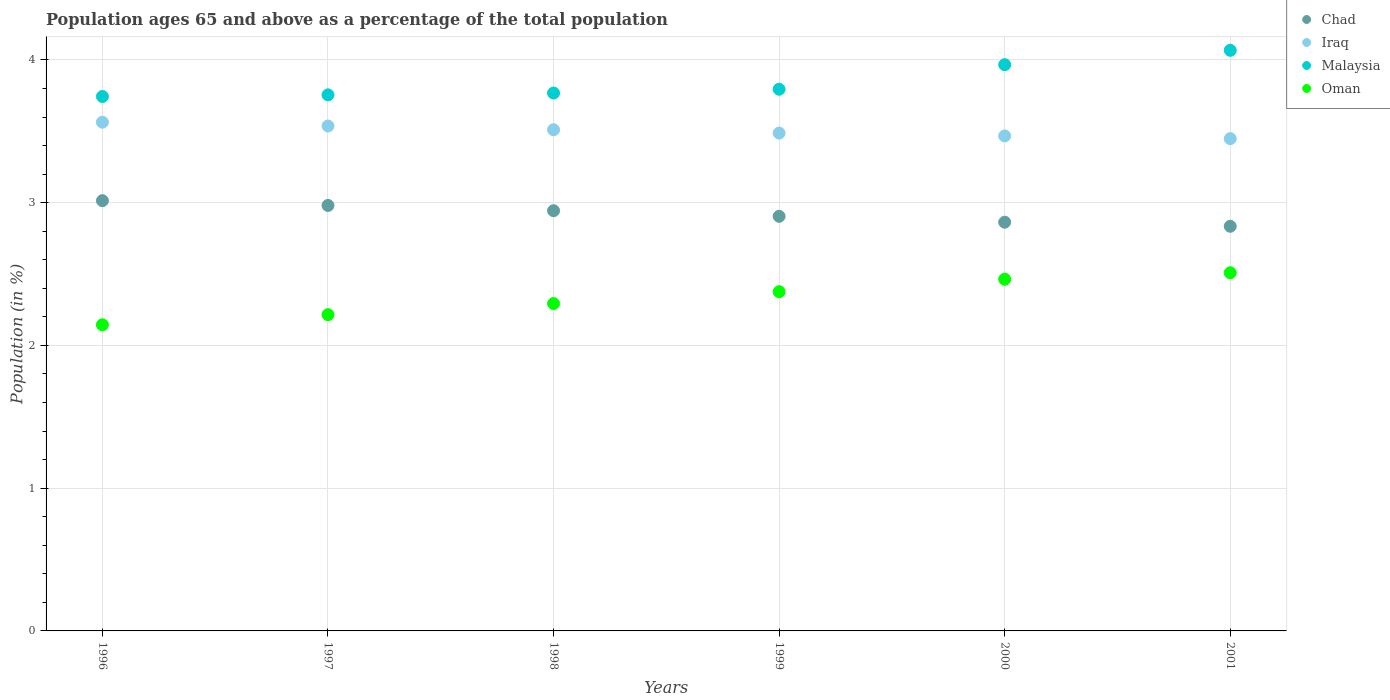How many different coloured dotlines are there?
Your response must be concise. 4. Is the number of dotlines equal to the number of legend labels?
Keep it short and to the point. Yes. What is the percentage of the population ages 65 and above in Iraq in 1996?
Provide a short and direct response. 3.56. Across all years, what is the maximum percentage of the population ages 65 and above in Iraq?
Provide a short and direct response. 3.56. Across all years, what is the minimum percentage of the population ages 65 and above in Iraq?
Keep it short and to the point. 3.45. In which year was the percentage of the population ages 65 and above in Malaysia maximum?
Give a very brief answer. 2001. In which year was the percentage of the population ages 65 and above in Malaysia minimum?
Offer a terse response. 1996. What is the total percentage of the population ages 65 and above in Oman in the graph?
Your answer should be compact. 14. What is the difference between the percentage of the population ages 65 and above in Malaysia in 1997 and that in 2000?
Ensure brevity in your answer.  -0.21. What is the difference between the percentage of the population ages 65 and above in Oman in 1997 and the percentage of the population ages 65 and above in Malaysia in 1996?
Offer a very short reply. -1.53. What is the average percentage of the population ages 65 and above in Chad per year?
Your answer should be very brief. 2.92. In the year 2000, what is the difference between the percentage of the population ages 65 and above in Iraq and percentage of the population ages 65 and above in Oman?
Your answer should be very brief. 1. What is the ratio of the percentage of the population ages 65 and above in Oman in 1998 to that in 2000?
Your answer should be compact. 0.93. Is the percentage of the population ages 65 and above in Malaysia in 1997 less than that in 1999?
Offer a terse response. Yes. What is the difference between the highest and the second highest percentage of the population ages 65 and above in Malaysia?
Give a very brief answer. 0.1. What is the difference between the highest and the lowest percentage of the population ages 65 and above in Malaysia?
Your answer should be very brief. 0.32. How many years are there in the graph?
Offer a terse response. 6. Are the values on the major ticks of Y-axis written in scientific E-notation?
Your answer should be compact. No. Does the graph contain any zero values?
Offer a terse response. No. Does the graph contain grids?
Give a very brief answer. Yes. Where does the legend appear in the graph?
Provide a short and direct response. Top right. How many legend labels are there?
Give a very brief answer. 4. What is the title of the graph?
Offer a terse response. Population ages 65 and above as a percentage of the total population. Does "Mauritania" appear as one of the legend labels in the graph?
Give a very brief answer. No. What is the label or title of the X-axis?
Keep it short and to the point. Years. What is the label or title of the Y-axis?
Make the answer very short. Population (in %). What is the Population (in %) of Chad in 1996?
Provide a succinct answer. 3.01. What is the Population (in %) of Iraq in 1996?
Your answer should be very brief. 3.56. What is the Population (in %) of Malaysia in 1996?
Your answer should be very brief. 3.74. What is the Population (in %) of Oman in 1996?
Your response must be concise. 2.14. What is the Population (in %) in Chad in 1997?
Offer a very short reply. 2.98. What is the Population (in %) in Iraq in 1997?
Give a very brief answer. 3.54. What is the Population (in %) in Malaysia in 1997?
Make the answer very short. 3.76. What is the Population (in %) in Oman in 1997?
Provide a short and direct response. 2.22. What is the Population (in %) in Chad in 1998?
Ensure brevity in your answer.  2.94. What is the Population (in %) in Iraq in 1998?
Offer a terse response. 3.51. What is the Population (in %) of Malaysia in 1998?
Offer a terse response. 3.77. What is the Population (in %) in Oman in 1998?
Your answer should be very brief. 2.29. What is the Population (in %) in Chad in 1999?
Give a very brief answer. 2.9. What is the Population (in %) of Iraq in 1999?
Provide a succinct answer. 3.49. What is the Population (in %) of Malaysia in 1999?
Keep it short and to the point. 3.79. What is the Population (in %) in Oman in 1999?
Ensure brevity in your answer.  2.38. What is the Population (in %) in Chad in 2000?
Ensure brevity in your answer.  2.86. What is the Population (in %) of Iraq in 2000?
Ensure brevity in your answer.  3.47. What is the Population (in %) of Malaysia in 2000?
Offer a very short reply. 3.97. What is the Population (in %) in Oman in 2000?
Provide a succinct answer. 2.46. What is the Population (in %) in Chad in 2001?
Keep it short and to the point. 2.83. What is the Population (in %) in Iraq in 2001?
Your response must be concise. 3.45. What is the Population (in %) of Malaysia in 2001?
Make the answer very short. 4.07. What is the Population (in %) of Oman in 2001?
Ensure brevity in your answer.  2.51. Across all years, what is the maximum Population (in %) in Chad?
Your answer should be compact. 3.01. Across all years, what is the maximum Population (in %) in Iraq?
Offer a very short reply. 3.56. Across all years, what is the maximum Population (in %) in Malaysia?
Offer a very short reply. 4.07. Across all years, what is the maximum Population (in %) of Oman?
Provide a short and direct response. 2.51. Across all years, what is the minimum Population (in %) of Chad?
Offer a very short reply. 2.83. Across all years, what is the minimum Population (in %) of Iraq?
Your answer should be very brief. 3.45. Across all years, what is the minimum Population (in %) in Malaysia?
Your answer should be compact. 3.74. Across all years, what is the minimum Population (in %) in Oman?
Give a very brief answer. 2.14. What is the total Population (in %) of Chad in the graph?
Keep it short and to the point. 17.54. What is the total Population (in %) in Iraq in the graph?
Your answer should be very brief. 21.02. What is the total Population (in %) in Malaysia in the graph?
Your answer should be very brief. 23.1. What is the total Population (in %) in Oman in the graph?
Offer a terse response. 14. What is the difference between the Population (in %) in Chad in 1996 and that in 1997?
Keep it short and to the point. 0.03. What is the difference between the Population (in %) in Iraq in 1996 and that in 1997?
Offer a terse response. 0.03. What is the difference between the Population (in %) in Malaysia in 1996 and that in 1997?
Your response must be concise. -0.01. What is the difference between the Population (in %) in Oman in 1996 and that in 1997?
Offer a very short reply. -0.07. What is the difference between the Population (in %) of Chad in 1996 and that in 1998?
Provide a succinct answer. 0.07. What is the difference between the Population (in %) in Iraq in 1996 and that in 1998?
Ensure brevity in your answer.  0.05. What is the difference between the Population (in %) in Malaysia in 1996 and that in 1998?
Offer a terse response. -0.02. What is the difference between the Population (in %) of Oman in 1996 and that in 1998?
Make the answer very short. -0.15. What is the difference between the Population (in %) of Chad in 1996 and that in 1999?
Keep it short and to the point. 0.11. What is the difference between the Population (in %) in Iraq in 1996 and that in 1999?
Your answer should be very brief. 0.08. What is the difference between the Population (in %) in Malaysia in 1996 and that in 1999?
Make the answer very short. -0.05. What is the difference between the Population (in %) of Oman in 1996 and that in 1999?
Your answer should be compact. -0.23. What is the difference between the Population (in %) of Chad in 1996 and that in 2000?
Make the answer very short. 0.15. What is the difference between the Population (in %) of Iraq in 1996 and that in 2000?
Your answer should be very brief. 0.1. What is the difference between the Population (in %) of Malaysia in 1996 and that in 2000?
Make the answer very short. -0.22. What is the difference between the Population (in %) in Oman in 1996 and that in 2000?
Provide a succinct answer. -0.32. What is the difference between the Population (in %) of Chad in 1996 and that in 2001?
Offer a terse response. 0.18. What is the difference between the Population (in %) in Iraq in 1996 and that in 2001?
Your answer should be very brief. 0.12. What is the difference between the Population (in %) of Malaysia in 1996 and that in 2001?
Provide a short and direct response. -0.32. What is the difference between the Population (in %) of Oman in 1996 and that in 2001?
Offer a very short reply. -0.36. What is the difference between the Population (in %) of Chad in 1997 and that in 1998?
Offer a very short reply. 0.04. What is the difference between the Population (in %) in Iraq in 1997 and that in 1998?
Provide a short and direct response. 0.03. What is the difference between the Population (in %) of Malaysia in 1997 and that in 1998?
Your response must be concise. -0.01. What is the difference between the Population (in %) in Oman in 1997 and that in 1998?
Keep it short and to the point. -0.08. What is the difference between the Population (in %) in Chad in 1997 and that in 1999?
Offer a terse response. 0.08. What is the difference between the Population (in %) in Iraq in 1997 and that in 1999?
Offer a very short reply. 0.05. What is the difference between the Population (in %) of Malaysia in 1997 and that in 1999?
Make the answer very short. -0.04. What is the difference between the Population (in %) of Oman in 1997 and that in 1999?
Your answer should be very brief. -0.16. What is the difference between the Population (in %) in Chad in 1997 and that in 2000?
Provide a short and direct response. 0.12. What is the difference between the Population (in %) of Iraq in 1997 and that in 2000?
Provide a short and direct response. 0.07. What is the difference between the Population (in %) of Malaysia in 1997 and that in 2000?
Make the answer very short. -0.21. What is the difference between the Population (in %) in Oman in 1997 and that in 2000?
Provide a succinct answer. -0.25. What is the difference between the Population (in %) in Chad in 1997 and that in 2001?
Your response must be concise. 0.15. What is the difference between the Population (in %) of Iraq in 1997 and that in 2001?
Make the answer very short. 0.09. What is the difference between the Population (in %) in Malaysia in 1997 and that in 2001?
Offer a terse response. -0.31. What is the difference between the Population (in %) in Oman in 1997 and that in 2001?
Make the answer very short. -0.29. What is the difference between the Population (in %) in Chad in 1998 and that in 1999?
Provide a short and direct response. 0.04. What is the difference between the Population (in %) of Iraq in 1998 and that in 1999?
Keep it short and to the point. 0.02. What is the difference between the Population (in %) in Malaysia in 1998 and that in 1999?
Give a very brief answer. -0.03. What is the difference between the Population (in %) in Oman in 1998 and that in 1999?
Your answer should be compact. -0.08. What is the difference between the Population (in %) of Chad in 1998 and that in 2000?
Your response must be concise. 0.08. What is the difference between the Population (in %) in Iraq in 1998 and that in 2000?
Give a very brief answer. 0.04. What is the difference between the Population (in %) in Malaysia in 1998 and that in 2000?
Your answer should be very brief. -0.2. What is the difference between the Population (in %) of Oman in 1998 and that in 2000?
Give a very brief answer. -0.17. What is the difference between the Population (in %) of Chad in 1998 and that in 2001?
Offer a terse response. 0.11. What is the difference between the Population (in %) in Iraq in 1998 and that in 2001?
Provide a short and direct response. 0.06. What is the difference between the Population (in %) of Malaysia in 1998 and that in 2001?
Keep it short and to the point. -0.3. What is the difference between the Population (in %) in Oman in 1998 and that in 2001?
Make the answer very short. -0.22. What is the difference between the Population (in %) of Chad in 1999 and that in 2000?
Your answer should be very brief. 0.04. What is the difference between the Population (in %) in Iraq in 1999 and that in 2000?
Your response must be concise. 0.02. What is the difference between the Population (in %) of Malaysia in 1999 and that in 2000?
Ensure brevity in your answer.  -0.17. What is the difference between the Population (in %) in Oman in 1999 and that in 2000?
Give a very brief answer. -0.09. What is the difference between the Population (in %) in Chad in 1999 and that in 2001?
Your response must be concise. 0.07. What is the difference between the Population (in %) in Iraq in 1999 and that in 2001?
Your response must be concise. 0.04. What is the difference between the Population (in %) of Malaysia in 1999 and that in 2001?
Provide a succinct answer. -0.27. What is the difference between the Population (in %) of Oman in 1999 and that in 2001?
Provide a succinct answer. -0.13. What is the difference between the Population (in %) in Chad in 2000 and that in 2001?
Offer a very short reply. 0.03. What is the difference between the Population (in %) in Iraq in 2000 and that in 2001?
Your answer should be compact. 0.02. What is the difference between the Population (in %) of Malaysia in 2000 and that in 2001?
Keep it short and to the point. -0.1. What is the difference between the Population (in %) in Oman in 2000 and that in 2001?
Offer a very short reply. -0.05. What is the difference between the Population (in %) of Chad in 1996 and the Population (in %) of Iraq in 1997?
Offer a very short reply. -0.52. What is the difference between the Population (in %) of Chad in 1996 and the Population (in %) of Malaysia in 1997?
Keep it short and to the point. -0.74. What is the difference between the Population (in %) of Chad in 1996 and the Population (in %) of Oman in 1997?
Provide a succinct answer. 0.8. What is the difference between the Population (in %) of Iraq in 1996 and the Population (in %) of Malaysia in 1997?
Give a very brief answer. -0.19. What is the difference between the Population (in %) of Iraq in 1996 and the Population (in %) of Oman in 1997?
Your answer should be very brief. 1.35. What is the difference between the Population (in %) in Malaysia in 1996 and the Population (in %) in Oman in 1997?
Your response must be concise. 1.53. What is the difference between the Population (in %) in Chad in 1996 and the Population (in %) in Iraq in 1998?
Provide a short and direct response. -0.5. What is the difference between the Population (in %) of Chad in 1996 and the Population (in %) of Malaysia in 1998?
Keep it short and to the point. -0.75. What is the difference between the Population (in %) of Chad in 1996 and the Population (in %) of Oman in 1998?
Offer a very short reply. 0.72. What is the difference between the Population (in %) in Iraq in 1996 and the Population (in %) in Malaysia in 1998?
Ensure brevity in your answer.  -0.2. What is the difference between the Population (in %) of Iraq in 1996 and the Population (in %) of Oman in 1998?
Ensure brevity in your answer.  1.27. What is the difference between the Population (in %) of Malaysia in 1996 and the Population (in %) of Oman in 1998?
Keep it short and to the point. 1.45. What is the difference between the Population (in %) of Chad in 1996 and the Population (in %) of Iraq in 1999?
Offer a terse response. -0.47. What is the difference between the Population (in %) in Chad in 1996 and the Population (in %) in Malaysia in 1999?
Provide a short and direct response. -0.78. What is the difference between the Population (in %) of Chad in 1996 and the Population (in %) of Oman in 1999?
Give a very brief answer. 0.64. What is the difference between the Population (in %) in Iraq in 1996 and the Population (in %) in Malaysia in 1999?
Your response must be concise. -0.23. What is the difference between the Population (in %) of Iraq in 1996 and the Population (in %) of Oman in 1999?
Make the answer very short. 1.19. What is the difference between the Population (in %) in Malaysia in 1996 and the Population (in %) in Oman in 1999?
Provide a short and direct response. 1.37. What is the difference between the Population (in %) in Chad in 1996 and the Population (in %) in Iraq in 2000?
Keep it short and to the point. -0.45. What is the difference between the Population (in %) of Chad in 1996 and the Population (in %) of Malaysia in 2000?
Ensure brevity in your answer.  -0.95. What is the difference between the Population (in %) in Chad in 1996 and the Population (in %) in Oman in 2000?
Offer a very short reply. 0.55. What is the difference between the Population (in %) of Iraq in 1996 and the Population (in %) of Malaysia in 2000?
Offer a very short reply. -0.4. What is the difference between the Population (in %) of Iraq in 1996 and the Population (in %) of Oman in 2000?
Provide a succinct answer. 1.1. What is the difference between the Population (in %) of Malaysia in 1996 and the Population (in %) of Oman in 2000?
Provide a short and direct response. 1.28. What is the difference between the Population (in %) in Chad in 1996 and the Population (in %) in Iraq in 2001?
Your response must be concise. -0.43. What is the difference between the Population (in %) in Chad in 1996 and the Population (in %) in Malaysia in 2001?
Ensure brevity in your answer.  -1.05. What is the difference between the Population (in %) of Chad in 1996 and the Population (in %) of Oman in 2001?
Provide a short and direct response. 0.5. What is the difference between the Population (in %) in Iraq in 1996 and the Population (in %) in Malaysia in 2001?
Offer a very short reply. -0.5. What is the difference between the Population (in %) of Iraq in 1996 and the Population (in %) of Oman in 2001?
Your answer should be compact. 1.05. What is the difference between the Population (in %) in Malaysia in 1996 and the Population (in %) in Oman in 2001?
Offer a terse response. 1.23. What is the difference between the Population (in %) of Chad in 1997 and the Population (in %) of Iraq in 1998?
Your answer should be compact. -0.53. What is the difference between the Population (in %) in Chad in 1997 and the Population (in %) in Malaysia in 1998?
Offer a terse response. -0.79. What is the difference between the Population (in %) in Chad in 1997 and the Population (in %) in Oman in 1998?
Your answer should be compact. 0.69. What is the difference between the Population (in %) in Iraq in 1997 and the Population (in %) in Malaysia in 1998?
Make the answer very short. -0.23. What is the difference between the Population (in %) in Iraq in 1997 and the Population (in %) in Oman in 1998?
Make the answer very short. 1.24. What is the difference between the Population (in %) of Malaysia in 1997 and the Population (in %) of Oman in 1998?
Give a very brief answer. 1.46. What is the difference between the Population (in %) of Chad in 1997 and the Population (in %) of Iraq in 1999?
Give a very brief answer. -0.51. What is the difference between the Population (in %) of Chad in 1997 and the Population (in %) of Malaysia in 1999?
Your answer should be compact. -0.81. What is the difference between the Population (in %) in Chad in 1997 and the Population (in %) in Oman in 1999?
Offer a very short reply. 0.6. What is the difference between the Population (in %) of Iraq in 1997 and the Population (in %) of Malaysia in 1999?
Offer a very short reply. -0.26. What is the difference between the Population (in %) of Iraq in 1997 and the Population (in %) of Oman in 1999?
Offer a terse response. 1.16. What is the difference between the Population (in %) of Malaysia in 1997 and the Population (in %) of Oman in 1999?
Keep it short and to the point. 1.38. What is the difference between the Population (in %) of Chad in 1997 and the Population (in %) of Iraq in 2000?
Your answer should be compact. -0.49. What is the difference between the Population (in %) in Chad in 1997 and the Population (in %) in Malaysia in 2000?
Provide a succinct answer. -0.99. What is the difference between the Population (in %) of Chad in 1997 and the Population (in %) of Oman in 2000?
Provide a succinct answer. 0.52. What is the difference between the Population (in %) of Iraq in 1997 and the Population (in %) of Malaysia in 2000?
Offer a very short reply. -0.43. What is the difference between the Population (in %) of Iraq in 1997 and the Population (in %) of Oman in 2000?
Offer a very short reply. 1.07. What is the difference between the Population (in %) of Malaysia in 1997 and the Population (in %) of Oman in 2000?
Give a very brief answer. 1.29. What is the difference between the Population (in %) of Chad in 1997 and the Population (in %) of Iraq in 2001?
Ensure brevity in your answer.  -0.47. What is the difference between the Population (in %) of Chad in 1997 and the Population (in %) of Malaysia in 2001?
Your response must be concise. -1.09. What is the difference between the Population (in %) in Chad in 1997 and the Population (in %) in Oman in 2001?
Give a very brief answer. 0.47. What is the difference between the Population (in %) of Iraq in 1997 and the Population (in %) of Malaysia in 2001?
Keep it short and to the point. -0.53. What is the difference between the Population (in %) in Iraq in 1997 and the Population (in %) in Oman in 2001?
Offer a very short reply. 1.03. What is the difference between the Population (in %) in Malaysia in 1997 and the Population (in %) in Oman in 2001?
Your answer should be very brief. 1.25. What is the difference between the Population (in %) in Chad in 1998 and the Population (in %) in Iraq in 1999?
Provide a short and direct response. -0.54. What is the difference between the Population (in %) of Chad in 1998 and the Population (in %) of Malaysia in 1999?
Offer a very short reply. -0.85. What is the difference between the Population (in %) in Chad in 1998 and the Population (in %) in Oman in 1999?
Make the answer very short. 0.57. What is the difference between the Population (in %) of Iraq in 1998 and the Population (in %) of Malaysia in 1999?
Provide a short and direct response. -0.28. What is the difference between the Population (in %) of Iraq in 1998 and the Population (in %) of Oman in 1999?
Offer a very short reply. 1.13. What is the difference between the Population (in %) of Malaysia in 1998 and the Population (in %) of Oman in 1999?
Keep it short and to the point. 1.39. What is the difference between the Population (in %) in Chad in 1998 and the Population (in %) in Iraq in 2000?
Provide a succinct answer. -0.52. What is the difference between the Population (in %) in Chad in 1998 and the Population (in %) in Malaysia in 2000?
Make the answer very short. -1.02. What is the difference between the Population (in %) of Chad in 1998 and the Population (in %) of Oman in 2000?
Provide a succinct answer. 0.48. What is the difference between the Population (in %) of Iraq in 1998 and the Population (in %) of Malaysia in 2000?
Offer a terse response. -0.46. What is the difference between the Population (in %) of Iraq in 1998 and the Population (in %) of Oman in 2000?
Ensure brevity in your answer.  1.05. What is the difference between the Population (in %) in Malaysia in 1998 and the Population (in %) in Oman in 2000?
Provide a succinct answer. 1.3. What is the difference between the Population (in %) in Chad in 1998 and the Population (in %) in Iraq in 2001?
Offer a very short reply. -0.5. What is the difference between the Population (in %) of Chad in 1998 and the Population (in %) of Malaysia in 2001?
Your answer should be compact. -1.12. What is the difference between the Population (in %) in Chad in 1998 and the Population (in %) in Oman in 2001?
Your answer should be very brief. 0.43. What is the difference between the Population (in %) in Iraq in 1998 and the Population (in %) in Malaysia in 2001?
Your answer should be very brief. -0.56. What is the difference between the Population (in %) of Malaysia in 1998 and the Population (in %) of Oman in 2001?
Provide a short and direct response. 1.26. What is the difference between the Population (in %) in Chad in 1999 and the Population (in %) in Iraq in 2000?
Your answer should be compact. -0.56. What is the difference between the Population (in %) in Chad in 1999 and the Population (in %) in Malaysia in 2000?
Your response must be concise. -1.06. What is the difference between the Population (in %) of Chad in 1999 and the Population (in %) of Oman in 2000?
Make the answer very short. 0.44. What is the difference between the Population (in %) of Iraq in 1999 and the Population (in %) of Malaysia in 2000?
Make the answer very short. -0.48. What is the difference between the Population (in %) in Iraq in 1999 and the Population (in %) in Oman in 2000?
Your answer should be very brief. 1.02. What is the difference between the Population (in %) of Malaysia in 1999 and the Population (in %) of Oman in 2000?
Provide a short and direct response. 1.33. What is the difference between the Population (in %) of Chad in 1999 and the Population (in %) of Iraq in 2001?
Your response must be concise. -0.54. What is the difference between the Population (in %) in Chad in 1999 and the Population (in %) in Malaysia in 2001?
Your answer should be very brief. -1.16. What is the difference between the Population (in %) in Chad in 1999 and the Population (in %) in Oman in 2001?
Your answer should be compact. 0.4. What is the difference between the Population (in %) of Iraq in 1999 and the Population (in %) of Malaysia in 2001?
Provide a short and direct response. -0.58. What is the difference between the Population (in %) of Iraq in 1999 and the Population (in %) of Oman in 2001?
Keep it short and to the point. 0.98. What is the difference between the Population (in %) of Malaysia in 1999 and the Population (in %) of Oman in 2001?
Your answer should be compact. 1.29. What is the difference between the Population (in %) in Chad in 2000 and the Population (in %) in Iraq in 2001?
Your response must be concise. -0.59. What is the difference between the Population (in %) in Chad in 2000 and the Population (in %) in Malaysia in 2001?
Keep it short and to the point. -1.2. What is the difference between the Population (in %) of Chad in 2000 and the Population (in %) of Oman in 2001?
Your answer should be compact. 0.35. What is the difference between the Population (in %) of Iraq in 2000 and the Population (in %) of Malaysia in 2001?
Give a very brief answer. -0.6. What is the difference between the Population (in %) in Iraq in 2000 and the Population (in %) in Oman in 2001?
Make the answer very short. 0.96. What is the difference between the Population (in %) in Malaysia in 2000 and the Population (in %) in Oman in 2001?
Offer a very short reply. 1.46. What is the average Population (in %) of Chad per year?
Give a very brief answer. 2.92. What is the average Population (in %) in Iraq per year?
Ensure brevity in your answer.  3.5. What is the average Population (in %) in Malaysia per year?
Give a very brief answer. 3.85. What is the average Population (in %) in Oman per year?
Keep it short and to the point. 2.33. In the year 1996, what is the difference between the Population (in %) in Chad and Population (in %) in Iraq?
Keep it short and to the point. -0.55. In the year 1996, what is the difference between the Population (in %) of Chad and Population (in %) of Malaysia?
Provide a succinct answer. -0.73. In the year 1996, what is the difference between the Population (in %) in Chad and Population (in %) in Oman?
Provide a short and direct response. 0.87. In the year 1996, what is the difference between the Population (in %) in Iraq and Population (in %) in Malaysia?
Your answer should be compact. -0.18. In the year 1996, what is the difference between the Population (in %) of Iraq and Population (in %) of Oman?
Give a very brief answer. 1.42. In the year 1996, what is the difference between the Population (in %) of Malaysia and Population (in %) of Oman?
Give a very brief answer. 1.6. In the year 1997, what is the difference between the Population (in %) in Chad and Population (in %) in Iraq?
Your answer should be very brief. -0.56. In the year 1997, what is the difference between the Population (in %) in Chad and Population (in %) in Malaysia?
Provide a short and direct response. -0.77. In the year 1997, what is the difference between the Population (in %) in Chad and Population (in %) in Oman?
Provide a short and direct response. 0.76. In the year 1997, what is the difference between the Population (in %) in Iraq and Population (in %) in Malaysia?
Provide a short and direct response. -0.22. In the year 1997, what is the difference between the Population (in %) in Iraq and Population (in %) in Oman?
Offer a terse response. 1.32. In the year 1997, what is the difference between the Population (in %) in Malaysia and Population (in %) in Oman?
Make the answer very short. 1.54. In the year 1998, what is the difference between the Population (in %) of Chad and Population (in %) of Iraq?
Provide a short and direct response. -0.57. In the year 1998, what is the difference between the Population (in %) of Chad and Population (in %) of Malaysia?
Your answer should be very brief. -0.82. In the year 1998, what is the difference between the Population (in %) in Chad and Population (in %) in Oman?
Make the answer very short. 0.65. In the year 1998, what is the difference between the Population (in %) in Iraq and Population (in %) in Malaysia?
Offer a very short reply. -0.26. In the year 1998, what is the difference between the Population (in %) of Iraq and Population (in %) of Oman?
Keep it short and to the point. 1.22. In the year 1998, what is the difference between the Population (in %) in Malaysia and Population (in %) in Oman?
Offer a terse response. 1.47. In the year 1999, what is the difference between the Population (in %) in Chad and Population (in %) in Iraq?
Ensure brevity in your answer.  -0.58. In the year 1999, what is the difference between the Population (in %) in Chad and Population (in %) in Malaysia?
Your response must be concise. -0.89. In the year 1999, what is the difference between the Population (in %) in Chad and Population (in %) in Oman?
Provide a short and direct response. 0.53. In the year 1999, what is the difference between the Population (in %) in Iraq and Population (in %) in Malaysia?
Keep it short and to the point. -0.31. In the year 1999, what is the difference between the Population (in %) in Iraq and Population (in %) in Oman?
Offer a terse response. 1.11. In the year 1999, what is the difference between the Population (in %) in Malaysia and Population (in %) in Oman?
Your response must be concise. 1.42. In the year 2000, what is the difference between the Population (in %) of Chad and Population (in %) of Iraq?
Provide a succinct answer. -0.6. In the year 2000, what is the difference between the Population (in %) in Chad and Population (in %) in Malaysia?
Offer a terse response. -1.1. In the year 2000, what is the difference between the Population (in %) in Chad and Population (in %) in Oman?
Ensure brevity in your answer.  0.4. In the year 2000, what is the difference between the Population (in %) in Iraq and Population (in %) in Malaysia?
Ensure brevity in your answer.  -0.5. In the year 2000, what is the difference between the Population (in %) of Malaysia and Population (in %) of Oman?
Provide a succinct answer. 1.5. In the year 2001, what is the difference between the Population (in %) in Chad and Population (in %) in Iraq?
Your answer should be compact. -0.61. In the year 2001, what is the difference between the Population (in %) of Chad and Population (in %) of Malaysia?
Offer a terse response. -1.23. In the year 2001, what is the difference between the Population (in %) in Chad and Population (in %) in Oman?
Give a very brief answer. 0.33. In the year 2001, what is the difference between the Population (in %) in Iraq and Population (in %) in Malaysia?
Your answer should be compact. -0.62. In the year 2001, what is the difference between the Population (in %) of Iraq and Population (in %) of Oman?
Your answer should be compact. 0.94. In the year 2001, what is the difference between the Population (in %) of Malaysia and Population (in %) of Oman?
Make the answer very short. 1.56. What is the ratio of the Population (in %) of Chad in 1996 to that in 1997?
Your response must be concise. 1.01. What is the ratio of the Population (in %) of Iraq in 1996 to that in 1997?
Offer a terse response. 1.01. What is the ratio of the Population (in %) in Malaysia in 1996 to that in 1997?
Make the answer very short. 1. What is the ratio of the Population (in %) of Oman in 1996 to that in 1997?
Your response must be concise. 0.97. What is the ratio of the Population (in %) in Chad in 1996 to that in 1998?
Your answer should be compact. 1.02. What is the ratio of the Population (in %) in Oman in 1996 to that in 1998?
Your answer should be very brief. 0.94. What is the ratio of the Population (in %) in Chad in 1996 to that in 1999?
Your answer should be very brief. 1.04. What is the ratio of the Population (in %) in Iraq in 1996 to that in 1999?
Your answer should be very brief. 1.02. What is the ratio of the Population (in %) in Malaysia in 1996 to that in 1999?
Offer a terse response. 0.99. What is the ratio of the Population (in %) in Oman in 1996 to that in 1999?
Keep it short and to the point. 0.9. What is the ratio of the Population (in %) in Chad in 1996 to that in 2000?
Offer a very short reply. 1.05. What is the ratio of the Population (in %) of Iraq in 1996 to that in 2000?
Your answer should be very brief. 1.03. What is the ratio of the Population (in %) of Malaysia in 1996 to that in 2000?
Ensure brevity in your answer.  0.94. What is the ratio of the Population (in %) of Oman in 1996 to that in 2000?
Give a very brief answer. 0.87. What is the ratio of the Population (in %) of Chad in 1996 to that in 2001?
Make the answer very short. 1.06. What is the ratio of the Population (in %) of Iraq in 1996 to that in 2001?
Ensure brevity in your answer.  1.03. What is the ratio of the Population (in %) in Malaysia in 1996 to that in 2001?
Your response must be concise. 0.92. What is the ratio of the Population (in %) in Oman in 1996 to that in 2001?
Ensure brevity in your answer.  0.85. What is the ratio of the Population (in %) of Chad in 1997 to that in 1998?
Offer a terse response. 1.01. What is the ratio of the Population (in %) in Iraq in 1997 to that in 1998?
Make the answer very short. 1.01. What is the ratio of the Population (in %) of Chad in 1997 to that in 1999?
Ensure brevity in your answer.  1.03. What is the ratio of the Population (in %) in Iraq in 1997 to that in 1999?
Give a very brief answer. 1.01. What is the ratio of the Population (in %) of Malaysia in 1997 to that in 1999?
Your answer should be compact. 0.99. What is the ratio of the Population (in %) of Oman in 1997 to that in 1999?
Offer a terse response. 0.93. What is the ratio of the Population (in %) of Chad in 1997 to that in 2000?
Make the answer very short. 1.04. What is the ratio of the Population (in %) of Iraq in 1997 to that in 2000?
Your answer should be very brief. 1.02. What is the ratio of the Population (in %) in Malaysia in 1997 to that in 2000?
Offer a terse response. 0.95. What is the ratio of the Population (in %) of Oman in 1997 to that in 2000?
Your response must be concise. 0.9. What is the ratio of the Population (in %) of Chad in 1997 to that in 2001?
Make the answer very short. 1.05. What is the ratio of the Population (in %) in Iraq in 1997 to that in 2001?
Your answer should be very brief. 1.03. What is the ratio of the Population (in %) of Malaysia in 1997 to that in 2001?
Ensure brevity in your answer.  0.92. What is the ratio of the Population (in %) of Oman in 1997 to that in 2001?
Keep it short and to the point. 0.88. What is the ratio of the Population (in %) in Chad in 1998 to that in 1999?
Provide a succinct answer. 1.01. What is the ratio of the Population (in %) of Iraq in 1998 to that in 1999?
Provide a short and direct response. 1.01. What is the ratio of the Population (in %) of Malaysia in 1998 to that in 1999?
Keep it short and to the point. 0.99. What is the ratio of the Population (in %) of Oman in 1998 to that in 1999?
Provide a succinct answer. 0.97. What is the ratio of the Population (in %) in Chad in 1998 to that in 2000?
Make the answer very short. 1.03. What is the ratio of the Population (in %) in Iraq in 1998 to that in 2000?
Ensure brevity in your answer.  1.01. What is the ratio of the Population (in %) of Malaysia in 1998 to that in 2000?
Your answer should be compact. 0.95. What is the ratio of the Population (in %) of Oman in 1998 to that in 2000?
Give a very brief answer. 0.93. What is the ratio of the Population (in %) in Chad in 1998 to that in 2001?
Offer a terse response. 1.04. What is the ratio of the Population (in %) in Iraq in 1998 to that in 2001?
Your answer should be very brief. 1.02. What is the ratio of the Population (in %) of Malaysia in 1998 to that in 2001?
Offer a terse response. 0.93. What is the ratio of the Population (in %) of Oman in 1998 to that in 2001?
Make the answer very short. 0.91. What is the ratio of the Population (in %) of Chad in 1999 to that in 2000?
Keep it short and to the point. 1.01. What is the ratio of the Population (in %) in Iraq in 1999 to that in 2000?
Provide a succinct answer. 1.01. What is the ratio of the Population (in %) in Malaysia in 1999 to that in 2000?
Offer a terse response. 0.96. What is the ratio of the Population (in %) in Oman in 1999 to that in 2000?
Keep it short and to the point. 0.96. What is the ratio of the Population (in %) of Chad in 1999 to that in 2001?
Your response must be concise. 1.02. What is the ratio of the Population (in %) in Iraq in 1999 to that in 2001?
Offer a terse response. 1.01. What is the ratio of the Population (in %) of Malaysia in 1999 to that in 2001?
Your answer should be very brief. 0.93. What is the ratio of the Population (in %) in Oman in 1999 to that in 2001?
Make the answer very short. 0.95. What is the ratio of the Population (in %) of Iraq in 2000 to that in 2001?
Ensure brevity in your answer.  1.01. What is the ratio of the Population (in %) in Malaysia in 2000 to that in 2001?
Keep it short and to the point. 0.98. What is the ratio of the Population (in %) of Oman in 2000 to that in 2001?
Your answer should be very brief. 0.98. What is the difference between the highest and the second highest Population (in %) in Chad?
Give a very brief answer. 0.03. What is the difference between the highest and the second highest Population (in %) in Iraq?
Make the answer very short. 0.03. What is the difference between the highest and the second highest Population (in %) in Malaysia?
Provide a short and direct response. 0.1. What is the difference between the highest and the second highest Population (in %) of Oman?
Make the answer very short. 0.05. What is the difference between the highest and the lowest Population (in %) of Chad?
Offer a very short reply. 0.18. What is the difference between the highest and the lowest Population (in %) in Iraq?
Keep it short and to the point. 0.12. What is the difference between the highest and the lowest Population (in %) of Malaysia?
Provide a short and direct response. 0.32. What is the difference between the highest and the lowest Population (in %) in Oman?
Your response must be concise. 0.36. 